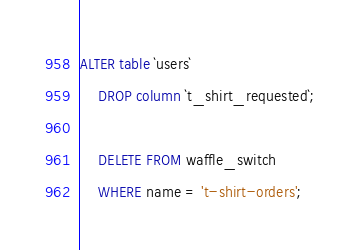<code> <loc_0><loc_0><loc_500><loc_500><_SQL_>ALTER table `users` 
    DROP column `t_shirt_requested`;

    DELETE FROM waffle_switch 
    WHERE name = 't-shirt-orders';
</code> 